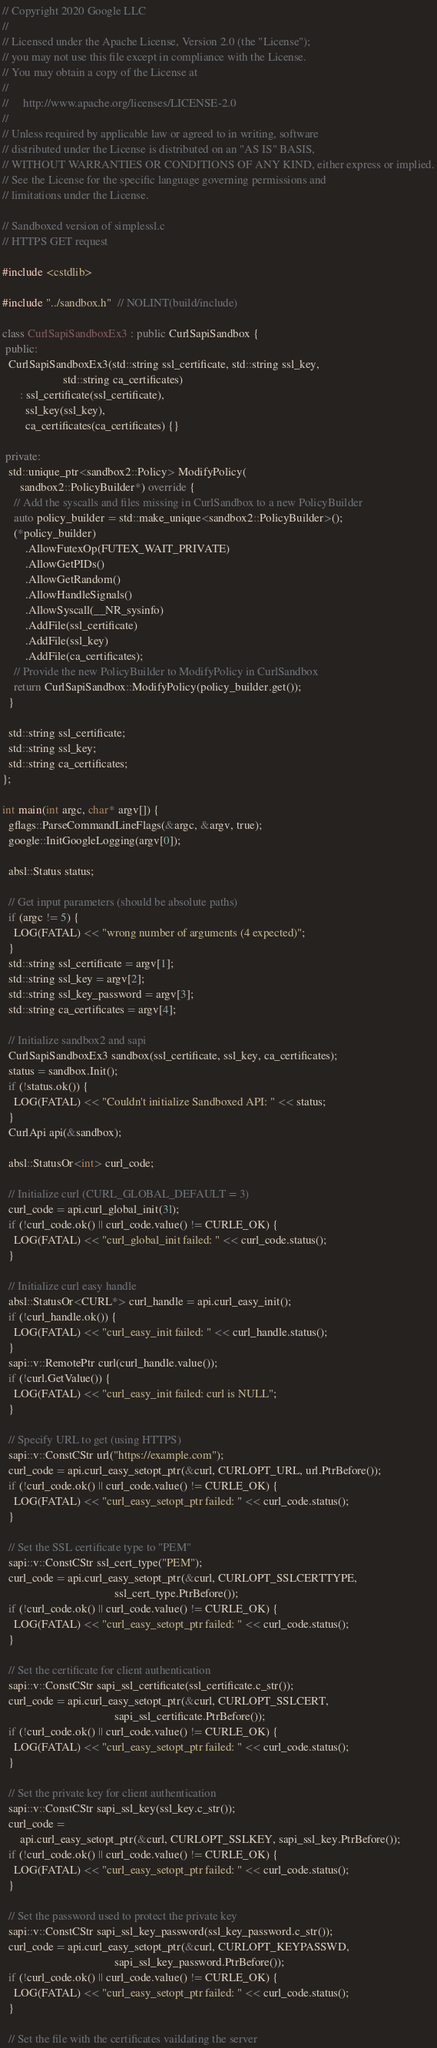<code> <loc_0><loc_0><loc_500><loc_500><_C++_>// Copyright 2020 Google LLC
//
// Licensed under the Apache License, Version 2.0 (the "License");
// you may not use this file except in compliance with the License.
// You may obtain a copy of the License at
//
//     http://www.apache.org/licenses/LICENSE-2.0
//
// Unless required by applicable law or agreed to in writing, software
// distributed under the License is distributed on an "AS IS" BASIS,
// WITHOUT WARRANTIES OR CONDITIONS OF ANY KIND, either express or implied.
// See the License for the specific language governing permissions and
// limitations under the License.

// Sandboxed version of simplessl.c
// HTTPS GET request

#include <cstdlib>

#include "../sandbox.h"  // NOLINT(build/include)

class CurlSapiSandboxEx3 : public CurlSapiSandbox {
 public:
  CurlSapiSandboxEx3(std::string ssl_certificate, std::string ssl_key,
                     std::string ca_certificates)
      : ssl_certificate(ssl_certificate),
        ssl_key(ssl_key),
        ca_certificates(ca_certificates) {}

 private:
  std::unique_ptr<sandbox2::Policy> ModifyPolicy(
      sandbox2::PolicyBuilder*) override {
    // Add the syscalls and files missing in CurlSandbox to a new PolicyBuilder
    auto policy_builder = std::make_unique<sandbox2::PolicyBuilder>();
    (*policy_builder)
        .AllowFutexOp(FUTEX_WAIT_PRIVATE)
        .AllowGetPIDs()
        .AllowGetRandom()
        .AllowHandleSignals()
        .AllowSyscall(__NR_sysinfo)
        .AddFile(ssl_certificate)
        .AddFile(ssl_key)
        .AddFile(ca_certificates);
    // Provide the new PolicyBuilder to ModifyPolicy in CurlSandbox
    return CurlSapiSandbox::ModifyPolicy(policy_builder.get());
  }

  std::string ssl_certificate;
  std::string ssl_key;
  std::string ca_certificates;
};

int main(int argc, char* argv[]) {
  gflags::ParseCommandLineFlags(&argc, &argv, true);
  google::InitGoogleLogging(argv[0]);

  absl::Status status;

  // Get input parameters (should be absolute paths)
  if (argc != 5) {
    LOG(FATAL) << "wrong number of arguments (4 expected)";
  }
  std::string ssl_certificate = argv[1];
  std::string ssl_key = argv[2];
  std::string ssl_key_password = argv[3];
  std::string ca_certificates = argv[4];

  // Initialize sandbox2 and sapi
  CurlSapiSandboxEx3 sandbox(ssl_certificate, ssl_key, ca_certificates);
  status = sandbox.Init();
  if (!status.ok()) {
    LOG(FATAL) << "Couldn't initialize Sandboxed API: " << status;
  }
  CurlApi api(&sandbox);

  absl::StatusOr<int> curl_code;

  // Initialize curl (CURL_GLOBAL_DEFAULT = 3)
  curl_code = api.curl_global_init(3l);
  if (!curl_code.ok() || curl_code.value() != CURLE_OK) {
    LOG(FATAL) << "curl_global_init failed: " << curl_code.status();
  }

  // Initialize curl easy handle
  absl::StatusOr<CURL*> curl_handle = api.curl_easy_init();
  if (!curl_handle.ok()) {
    LOG(FATAL) << "curl_easy_init failed: " << curl_handle.status();
  }
  sapi::v::RemotePtr curl(curl_handle.value());
  if (!curl.GetValue()) {
    LOG(FATAL) << "curl_easy_init failed: curl is NULL";
  }

  // Specify URL to get (using HTTPS)
  sapi::v::ConstCStr url("https://example.com");
  curl_code = api.curl_easy_setopt_ptr(&curl, CURLOPT_URL, url.PtrBefore());
  if (!curl_code.ok() || curl_code.value() != CURLE_OK) {
    LOG(FATAL) << "curl_easy_setopt_ptr failed: " << curl_code.status();
  }

  // Set the SSL certificate type to "PEM"
  sapi::v::ConstCStr ssl_cert_type("PEM");
  curl_code = api.curl_easy_setopt_ptr(&curl, CURLOPT_SSLCERTTYPE,
                                       ssl_cert_type.PtrBefore());
  if (!curl_code.ok() || curl_code.value() != CURLE_OK) {
    LOG(FATAL) << "curl_easy_setopt_ptr failed: " << curl_code.status();
  }

  // Set the certificate for client authentication
  sapi::v::ConstCStr sapi_ssl_certificate(ssl_certificate.c_str());
  curl_code = api.curl_easy_setopt_ptr(&curl, CURLOPT_SSLCERT,
                                       sapi_ssl_certificate.PtrBefore());
  if (!curl_code.ok() || curl_code.value() != CURLE_OK) {
    LOG(FATAL) << "curl_easy_setopt_ptr failed: " << curl_code.status();
  }

  // Set the private key for client authentication
  sapi::v::ConstCStr sapi_ssl_key(ssl_key.c_str());
  curl_code =
      api.curl_easy_setopt_ptr(&curl, CURLOPT_SSLKEY, sapi_ssl_key.PtrBefore());
  if (!curl_code.ok() || curl_code.value() != CURLE_OK) {
    LOG(FATAL) << "curl_easy_setopt_ptr failed: " << curl_code.status();
  }

  // Set the password used to protect the private key
  sapi::v::ConstCStr sapi_ssl_key_password(ssl_key_password.c_str());
  curl_code = api.curl_easy_setopt_ptr(&curl, CURLOPT_KEYPASSWD,
                                       sapi_ssl_key_password.PtrBefore());
  if (!curl_code.ok() || curl_code.value() != CURLE_OK) {
    LOG(FATAL) << "curl_easy_setopt_ptr failed: " << curl_code.status();
  }

  // Set the file with the certificates vaildating the server</code> 